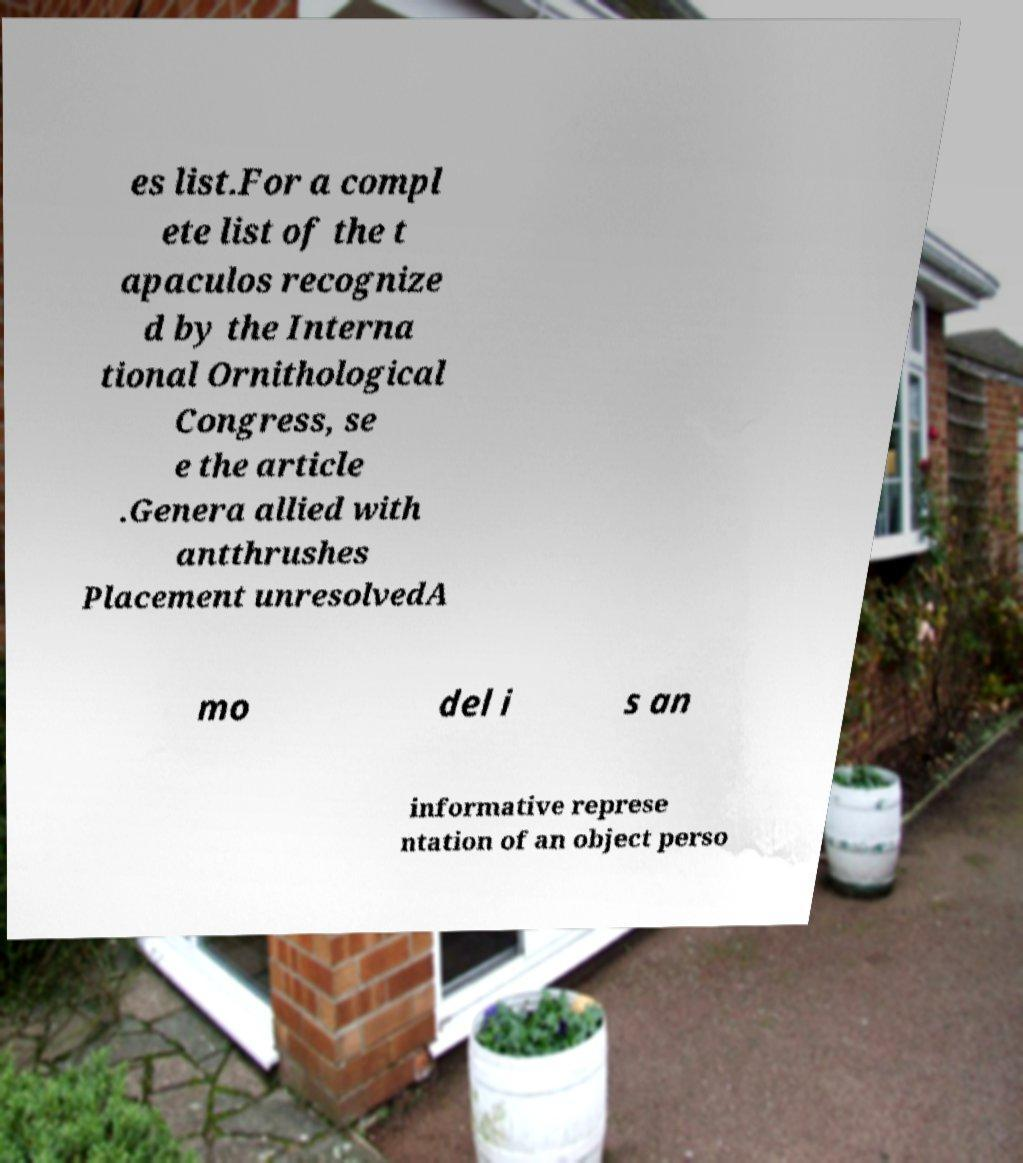For documentation purposes, I need the text within this image transcribed. Could you provide that? es list.For a compl ete list of the t apaculos recognize d by the Interna tional Ornithological Congress, se e the article .Genera allied with antthrushes Placement unresolvedA mo del i s an informative represe ntation of an object perso 